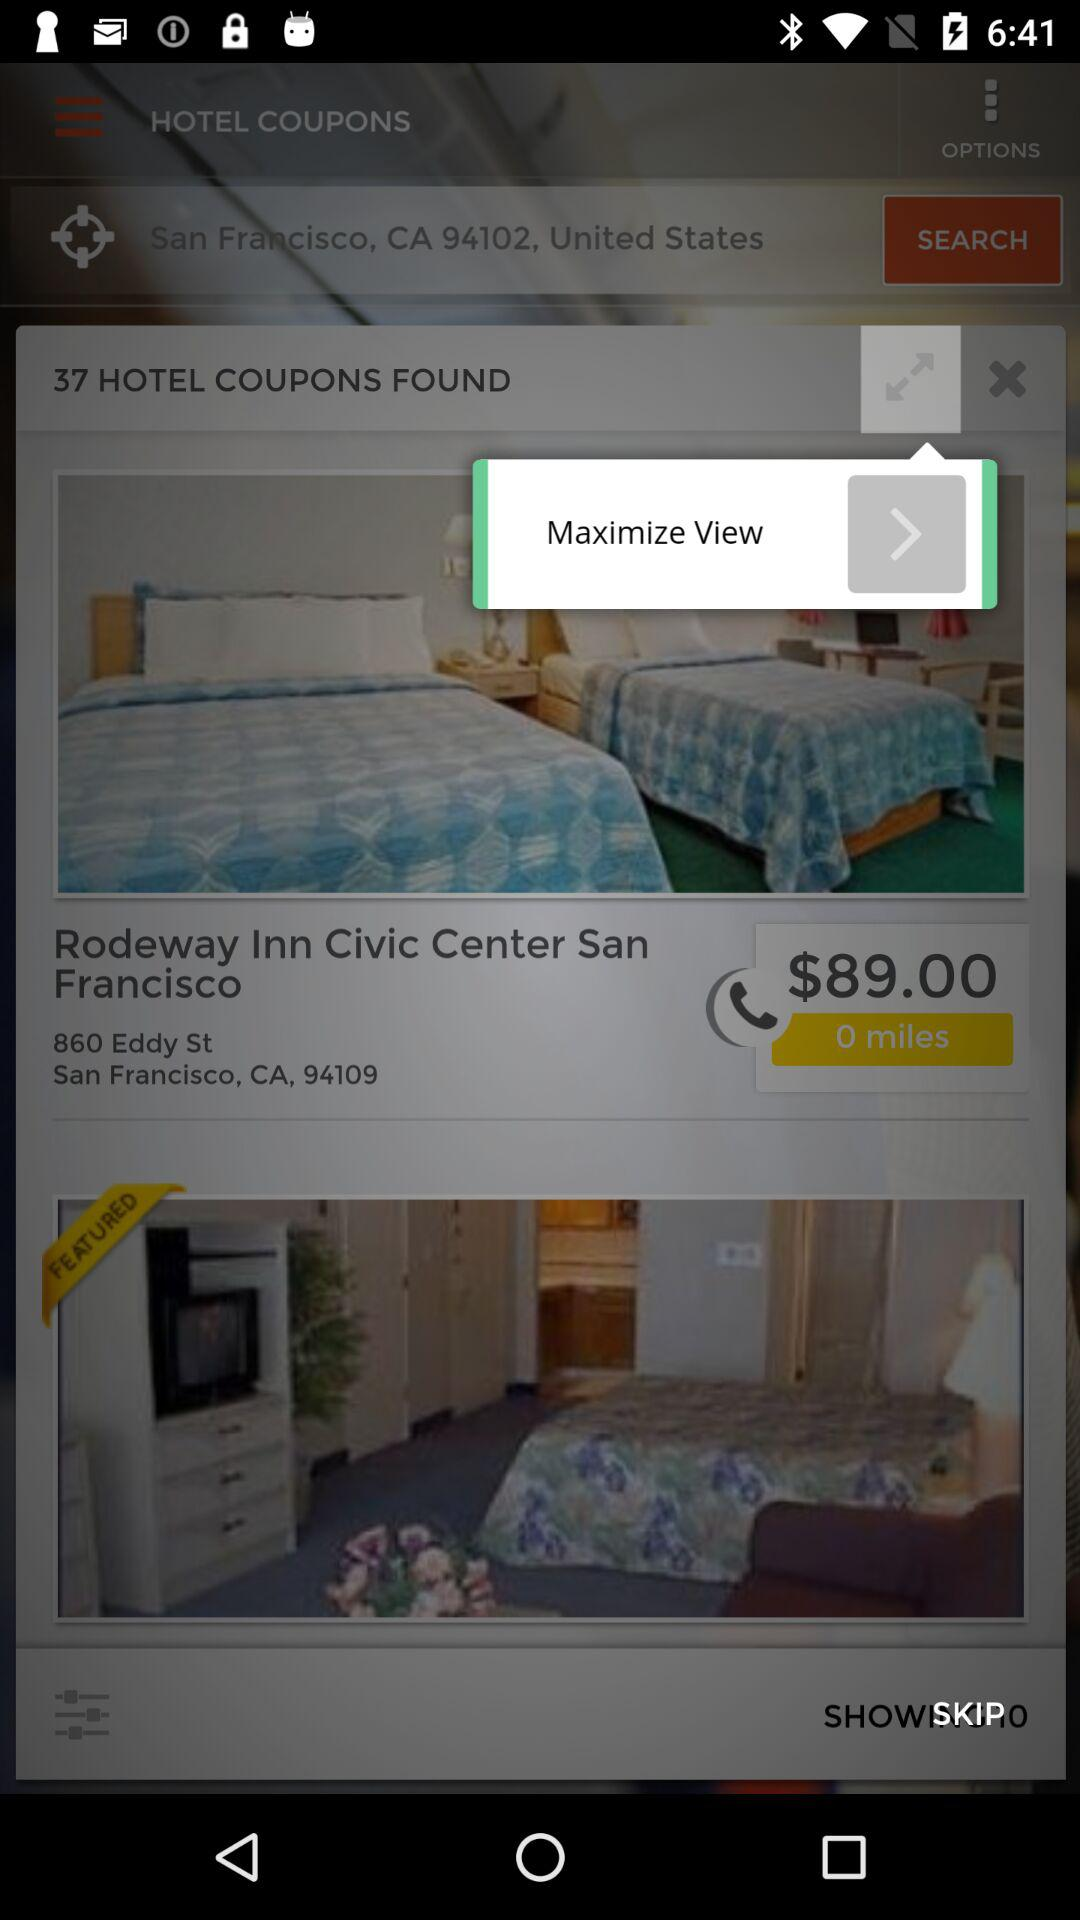How much is the hotel room per night?
Answer the question using a single word or phrase. $89.00 